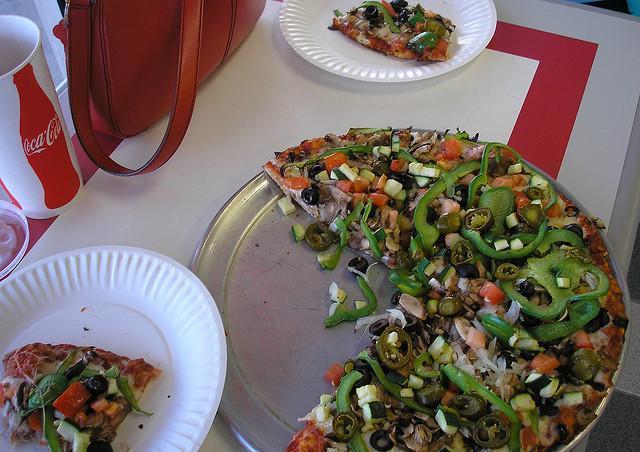How many pizzas can be seen?
Give a very brief answer. 3. How many people wearing red shirt?
Give a very brief answer. 0. 